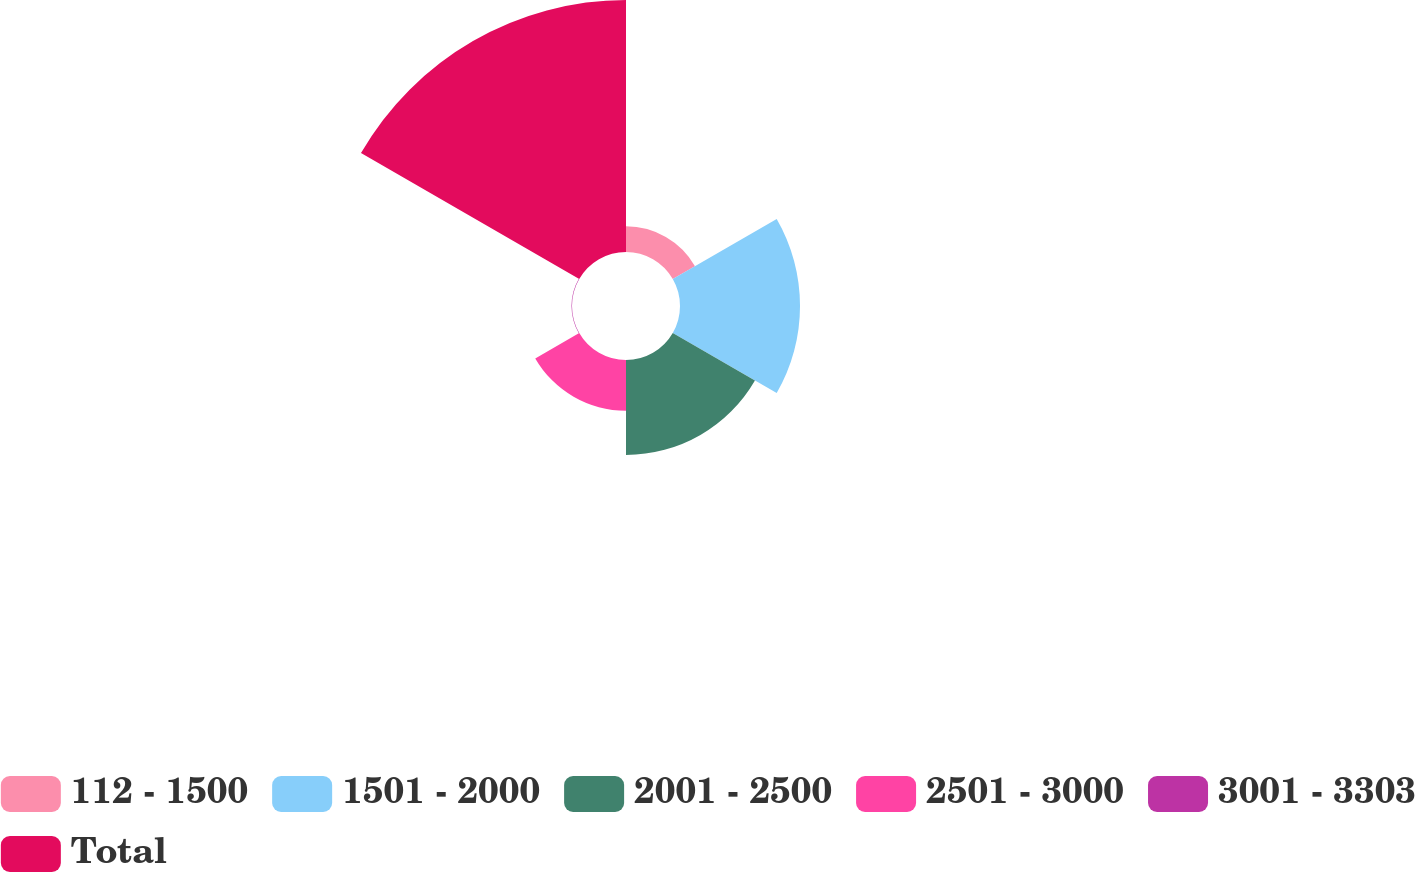Convert chart to OTSL. <chart><loc_0><loc_0><loc_500><loc_500><pie_chart><fcel>112 - 1500<fcel>1501 - 2000<fcel>2001 - 2500<fcel>2501 - 3000<fcel>3001 - 3303<fcel>Total<nl><fcel>4.72%<fcel>22.07%<fcel>17.45%<fcel>9.34%<fcel>0.09%<fcel>46.34%<nl></chart> 